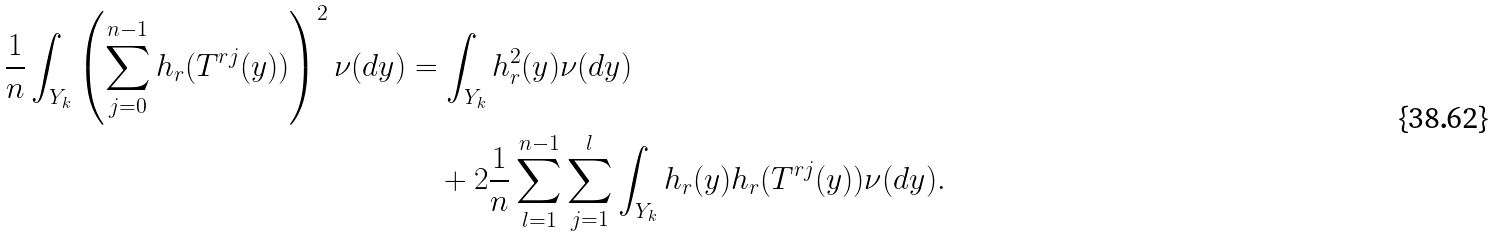<formula> <loc_0><loc_0><loc_500><loc_500>\frac { 1 } { n } \int _ { Y _ { k } } \left ( \sum _ { j = 0 } ^ { n - 1 } h _ { r } ( T ^ { r j } ( y ) ) \right ) ^ { 2 } \nu ( d y ) & = \int _ { Y _ { k } } h _ { r } ^ { 2 } ( y ) \nu ( d y ) \\ & \quad + 2 \frac { 1 } { n } \sum _ { l = 1 } ^ { n - 1 } \sum _ { j = 1 } ^ { l } \int _ { Y _ { k } } h _ { r } ( y ) h _ { r } ( T ^ { r j } ( y ) ) \nu ( d y ) .</formula> 